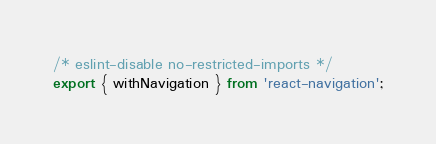<code> <loc_0><loc_0><loc_500><loc_500><_JavaScript_>
/* eslint-disable no-restricted-imports */
export { withNavigation } from 'react-navigation';
</code> 